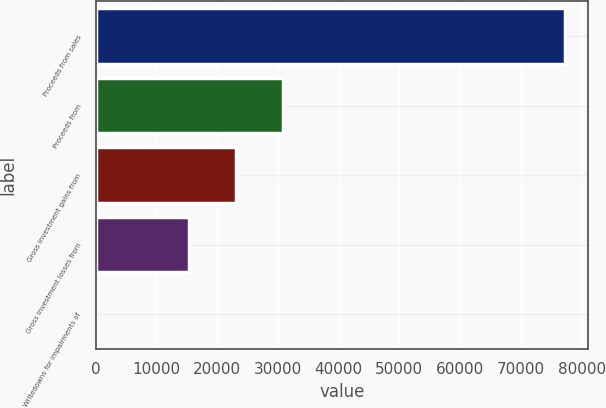<chart> <loc_0><loc_0><loc_500><loc_500><bar_chart><fcel>Proceeds from sales<fcel>Proceeds from<fcel>Gross investment gains from<fcel>Gross investment losses from<fcel>Writedowns for impairments of<nl><fcel>77224<fcel>30898<fcel>23177<fcel>15456<fcel>14<nl></chart> 